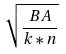<formula> <loc_0><loc_0><loc_500><loc_500>\sqrt { \frac { B A } { k * n } }</formula> 